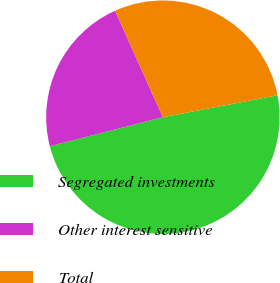Convert chart to OTSL. <chart><loc_0><loc_0><loc_500><loc_500><pie_chart><fcel>Segregated investments<fcel>Other interest sensitive<fcel>Total<nl><fcel>49.01%<fcel>22.28%<fcel>28.71%<nl></chart> 